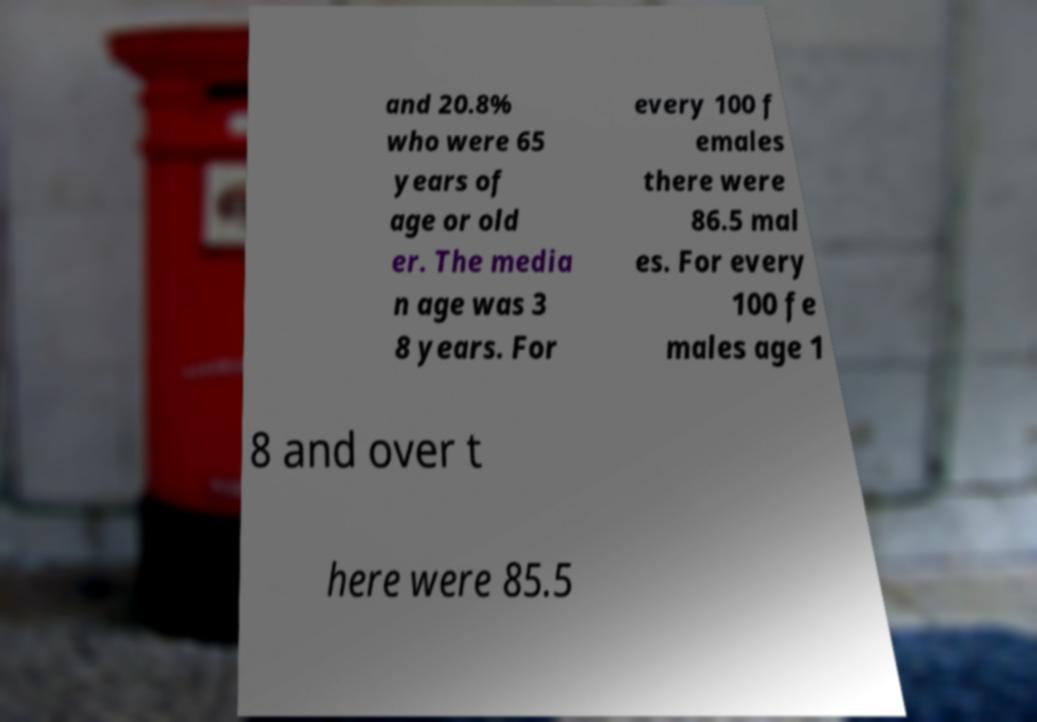I need the written content from this picture converted into text. Can you do that? and 20.8% who were 65 years of age or old er. The media n age was 3 8 years. For every 100 f emales there were 86.5 mal es. For every 100 fe males age 1 8 and over t here were 85.5 